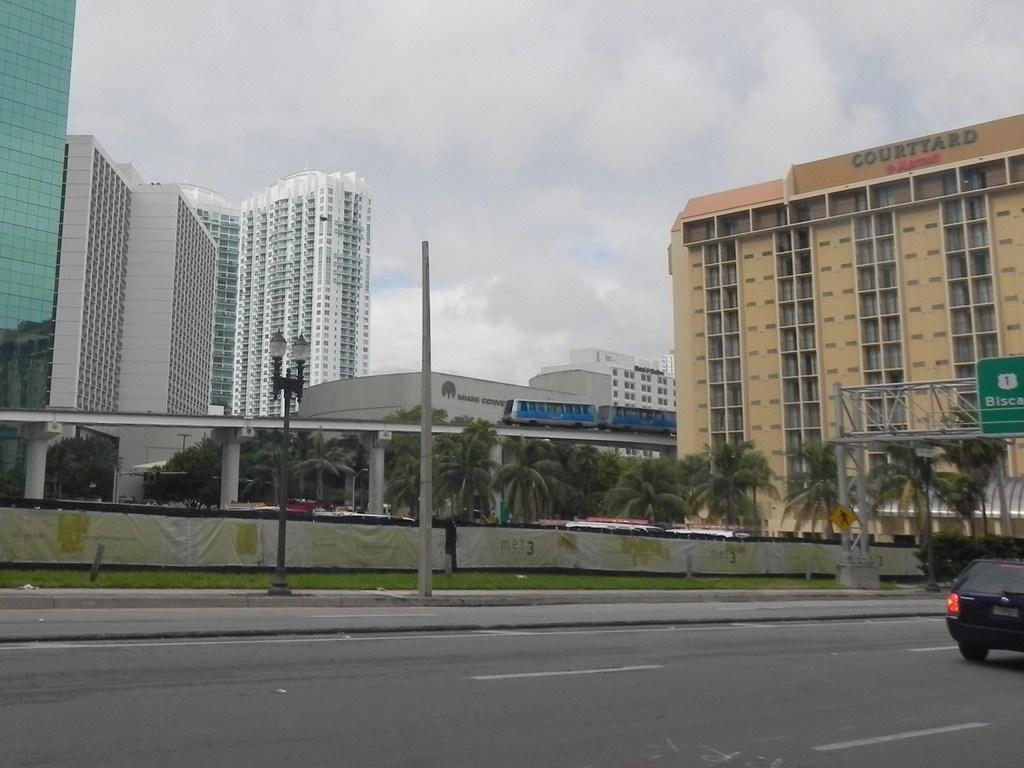Could you give a brief overview of what you see in this image? In this image we can see road and a car moving on road, there is grass, board, there are some trees and in the background of the image there are some buildings and top of the image there is clear sky. 